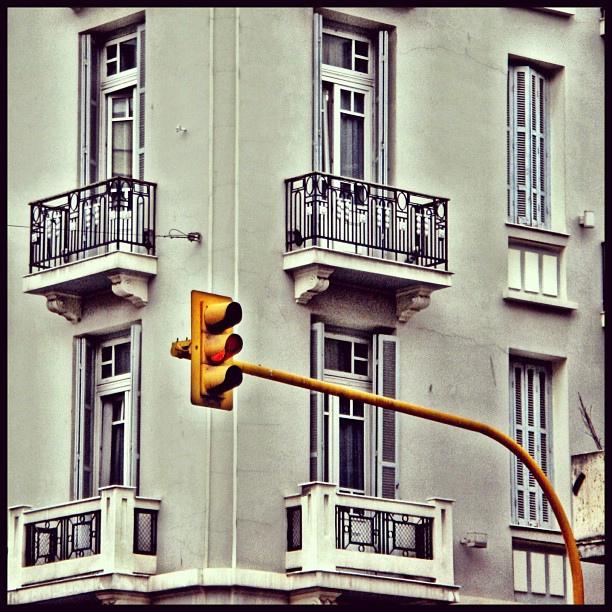Is the traffic light on red or green?
Answer briefly. Red. How many windows on the building in the background are open?
Write a very short answer. 1. Can the balcony's be used to sit outside?
Concise answer only. No. How many windows are shown?
Keep it brief. 6. What color light is lit on the traffic signal?
Concise answer only. Red. What color is the building?
Write a very short answer. Gray. IS the light red?
Concise answer only. Yes. Is the green traffic on?
Concise answer only. No. 